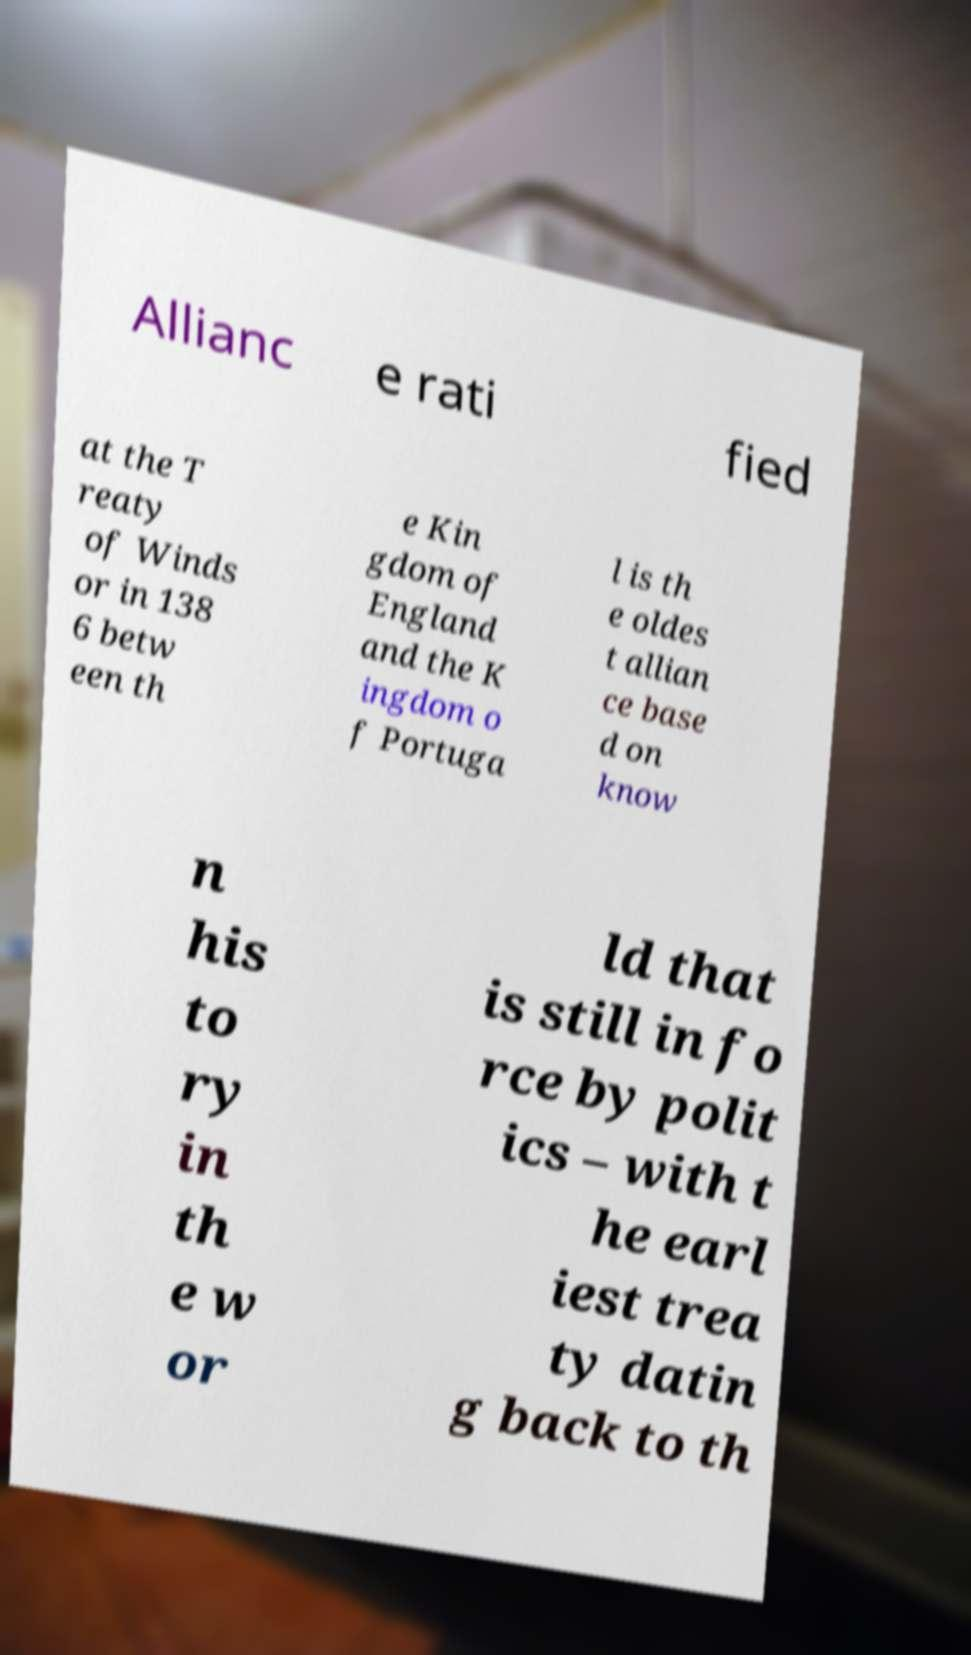Can you accurately transcribe the text from the provided image for me? Allianc e rati fied at the T reaty of Winds or in 138 6 betw een th e Kin gdom of England and the K ingdom o f Portuga l is th e oldes t allian ce base d on know n his to ry in th e w or ld that is still in fo rce by polit ics – with t he earl iest trea ty datin g back to th 